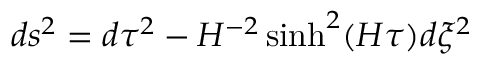Convert formula to latex. <formula><loc_0><loc_0><loc_500><loc_500>d s ^ { 2 } = d \tau ^ { 2 } - H ^ { - 2 } \sinh ^ { 2 } ( H \tau ) d \xi ^ { 2 }</formula> 